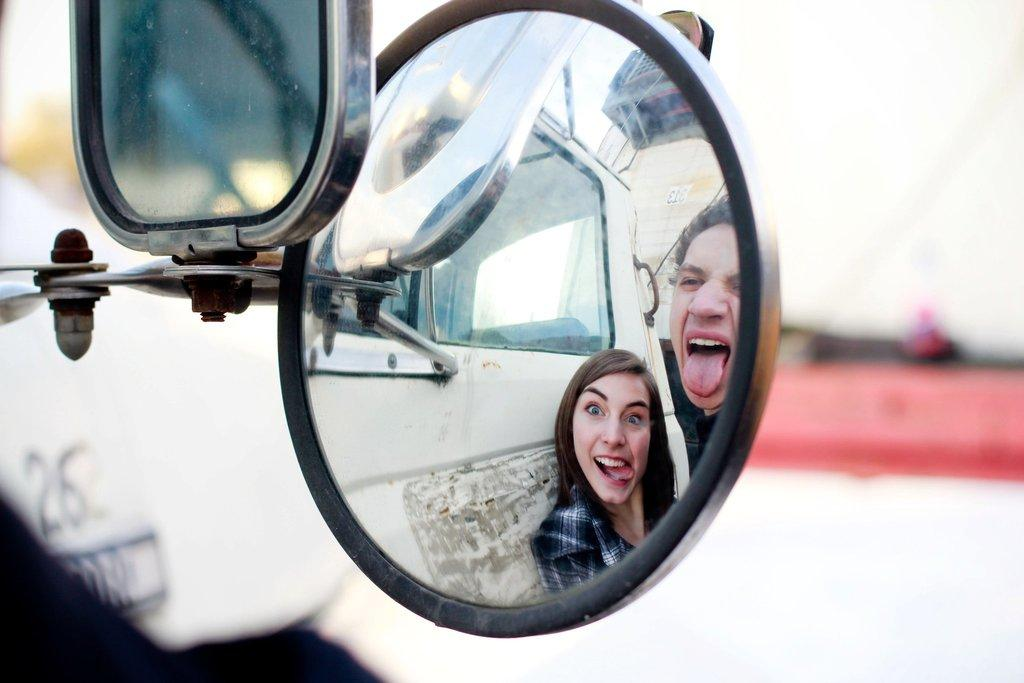How many mirrors are present in the image? There are two mirrors in the image. What can be seen in the reflection of one of the mirrors? The reflection of a vehicle and two people is visible in one of the mirrors. What is the quality of the background in the image? The background appears blurry. Who is the expert sitting in the passenger seat of the vehicle in the image? There is no expert or passenger mentioned in the image; it only shows the reflections of a vehicle and two people in the mirrors. 